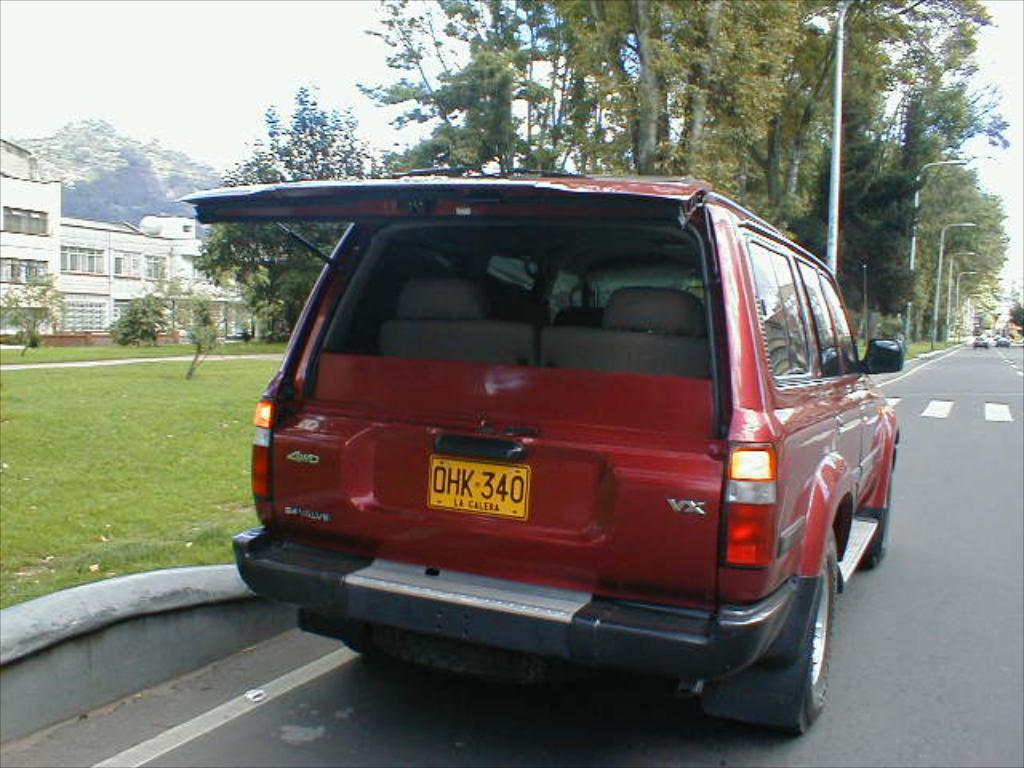What is parked on the road in the image? There is a vehicle parked on the road in the image. What can be seen in the background of the image? There is a building, a mountain, and trees in the backdrop of the image. What is the condition of the sky in the image? The sky is clear in the image. What type of flesh can be seen hanging from the trees in the image? There is no flesh hanging from the trees in the image; it features a vehicle parked on the road, a building, a mountain, and trees in the backdrop. Can you see a plane flying in the sky in the image? There is no plane visible in the sky in the image. 